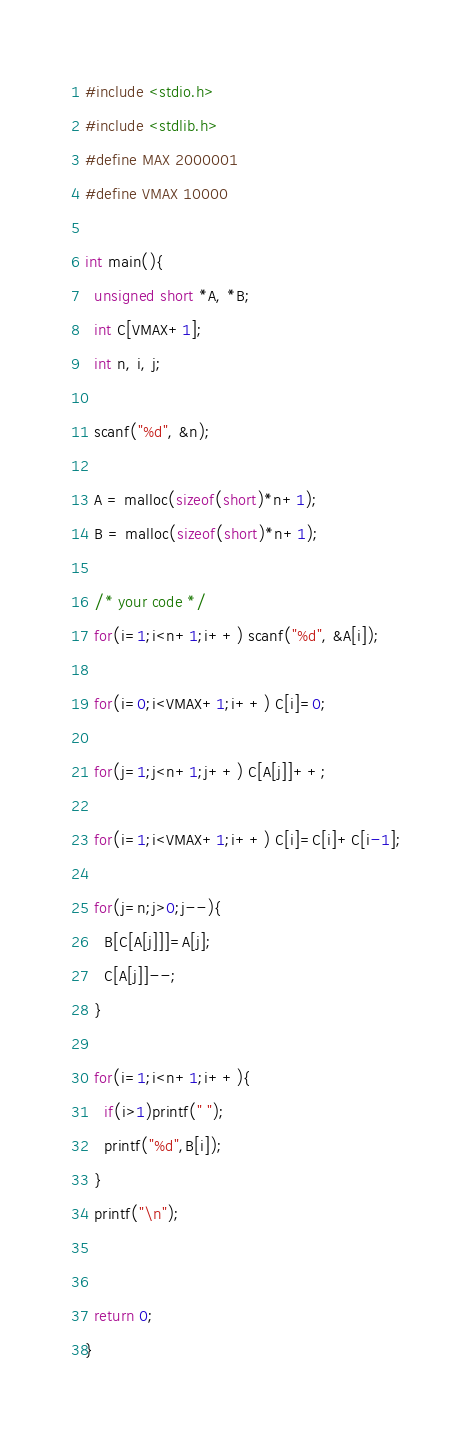Convert code to text. <code><loc_0><loc_0><loc_500><loc_500><_C_>#include <stdio.h>
#include <stdlib.h>
#define MAX 2000001
#define VMAX 10000

int main(){
  unsigned short *A, *B;
  int C[VMAX+1];
  int n, i, j;

  scanf("%d", &n);

  A = malloc(sizeof(short)*n+1);
  B = malloc(sizeof(short)*n+1);

  /* your code */
  for(i=1;i<n+1;i++) scanf("%d", &A[i]);

  for(i=0;i<VMAX+1;i++) C[i]=0;

  for(j=1;j<n+1;j++) C[A[j]]++;

  for(i=1;i<VMAX+1;i++) C[i]=C[i]+C[i-1];

  for(j=n;j>0;j--){
    B[C[A[j]]]=A[j];
    C[A[j]]--;
  }

  for(i=1;i<n+1;i++){
    if(i>1)printf(" ");
    printf("%d",B[i]);
  }
  printf("\n");


  return 0;
}

</code> 